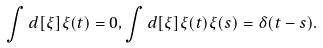<formula> <loc_0><loc_0><loc_500><loc_500>\int d [ \xi ] \xi ( t ) = 0 , \int d [ \xi ] \xi ( t ) \xi ( s ) = \delta ( t - s ) .</formula> 